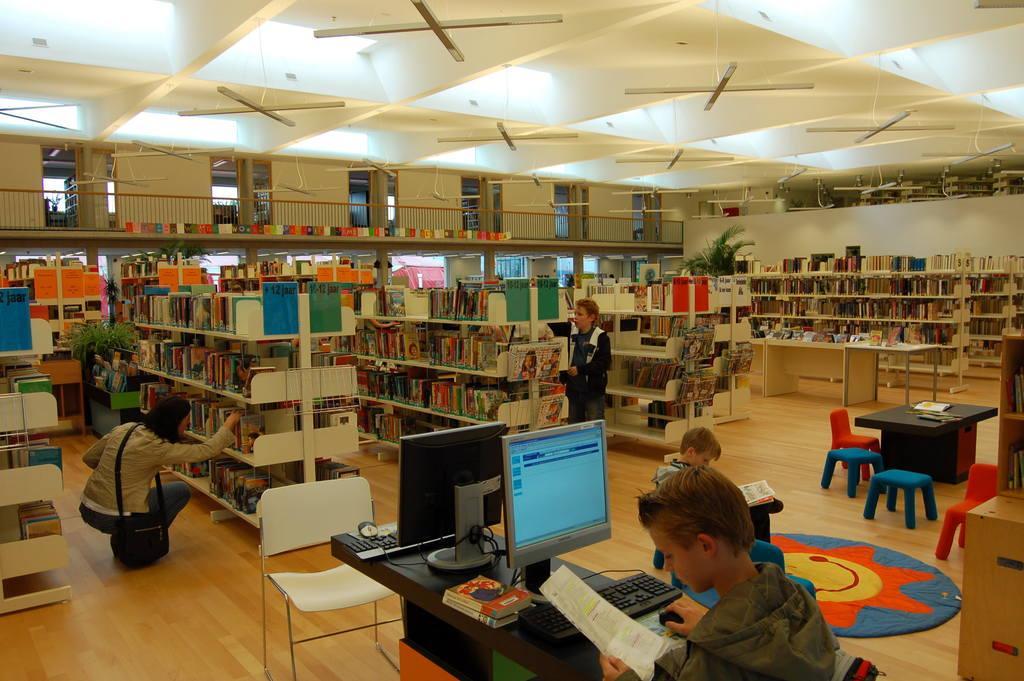In one or two sentences, can you explain what this image depicts? This is the picture of a place where we have some shelves in which there are some books arranged and around there are some other people and some chairs and tables on which there are some things and a laptop. 